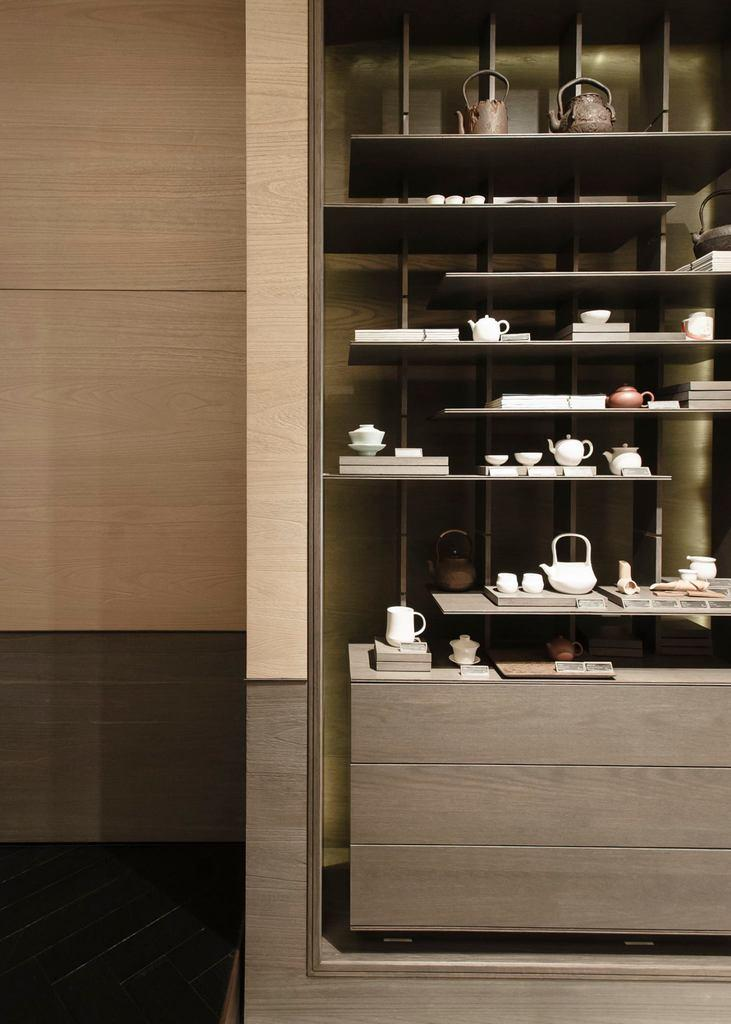What is the main object in the image? There is a rack in the image. What items can be seen on the rack? A teapot, cups, books, and other objects are present on the rack. Can you describe the background of the image? There is a wall in the background of the image. What type of verse can be heard recited by the egg in the image? There is no egg present in the image, and therefore no such recitation can be heard. 